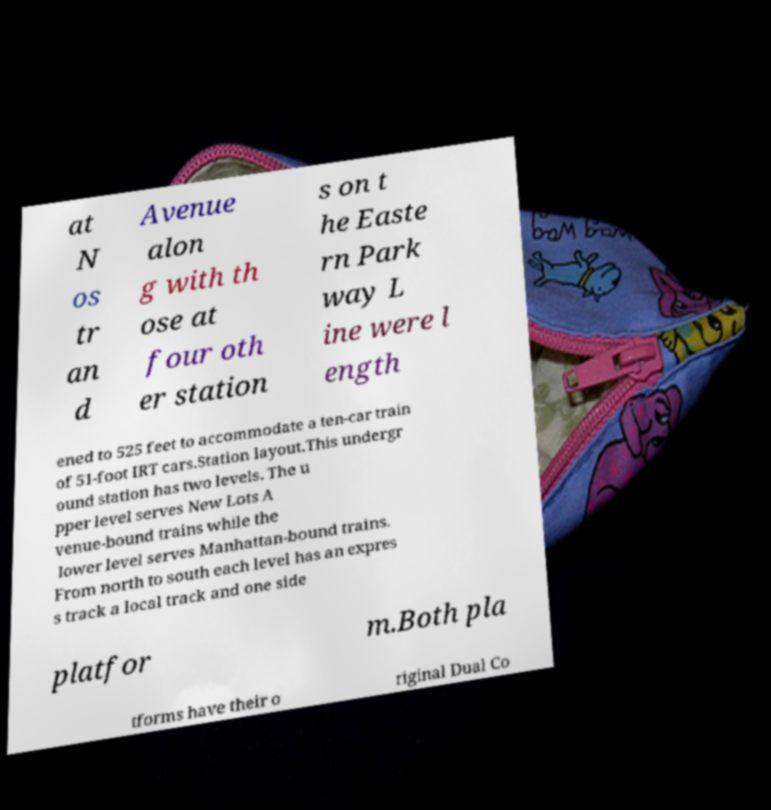Please identify and transcribe the text found in this image. at N os tr an d Avenue alon g with th ose at four oth er station s on t he Easte rn Park way L ine were l ength ened to 525 feet to accommodate a ten-car train of 51-foot IRT cars.Station layout.This undergr ound station has two levels. The u pper level serves New Lots A venue-bound trains while the lower level serves Manhattan-bound trains. From north to south each level has an expres s track a local track and one side platfor m.Both pla tforms have their o riginal Dual Co 